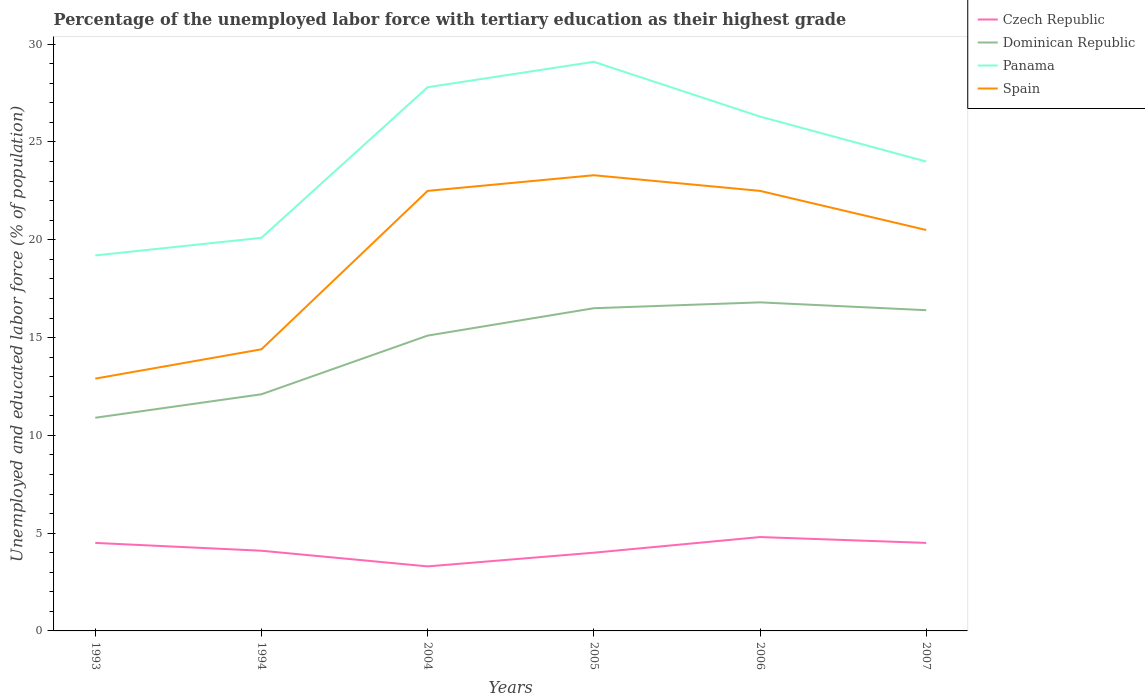How many different coloured lines are there?
Make the answer very short. 4. Is the number of lines equal to the number of legend labels?
Give a very brief answer. Yes. Across all years, what is the maximum percentage of the unemployed labor force with tertiary education in Czech Republic?
Keep it short and to the point. 3.3. What is the total percentage of the unemployed labor force with tertiary education in Spain in the graph?
Offer a very short reply. 2. What is the difference between the highest and the second highest percentage of the unemployed labor force with tertiary education in Panama?
Offer a terse response. 9.9. What is the difference between the highest and the lowest percentage of the unemployed labor force with tertiary education in Spain?
Offer a terse response. 4. Does the graph contain any zero values?
Provide a succinct answer. No. How many legend labels are there?
Offer a very short reply. 4. How are the legend labels stacked?
Your answer should be compact. Vertical. What is the title of the graph?
Provide a short and direct response. Percentage of the unemployed labor force with tertiary education as their highest grade. Does "World" appear as one of the legend labels in the graph?
Make the answer very short. No. What is the label or title of the Y-axis?
Offer a very short reply. Unemployed and educated labor force (% of population). What is the Unemployed and educated labor force (% of population) in Dominican Republic in 1993?
Provide a succinct answer. 10.9. What is the Unemployed and educated labor force (% of population) in Panama in 1993?
Offer a very short reply. 19.2. What is the Unemployed and educated labor force (% of population) of Spain in 1993?
Your answer should be compact. 12.9. What is the Unemployed and educated labor force (% of population) of Czech Republic in 1994?
Your answer should be very brief. 4.1. What is the Unemployed and educated labor force (% of population) in Dominican Republic in 1994?
Make the answer very short. 12.1. What is the Unemployed and educated labor force (% of population) of Panama in 1994?
Make the answer very short. 20.1. What is the Unemployed and educated labor force (% of population) of Spain in 1994?
Provide a succinct answer. 14.4. What is the Unemployed and educated labor force (% of population) of Czech Republic in 2004?
Ensure brevity in your answer.  3.3. What is the Unemployed and educated labor force (% of population) in Dominican Republic in 2004?
Your answer should be compact. 15.1. What is the Unemployed and educated labor force (% of population) of Panama in 2004?
Make the answer very short. 27.8. What is the Unemployed and educated labor force (% of population) of Panama in 2005?
Provide a short and direct response. 29.1. What is the Unemployed and educated labor force (% of population) of Spain in 2005?
Offer a terse response. 23.3. What is the Unemployed and educated labor force (% of population) of Czech Republic in 2006?
Your answer should be compact. 4.8. What is the Unemployed and educated labor force (% of population) of Dominican Republic in 2006?
Keep it short and to the point. 16.8. What is the Unemployed and educated labor force (% of population) of Panama in 2006?
Ensure brevity in your answer.  26.3. What is the Unemployed and educated labor force (% of population) in Czech Republic in 2007?
Keep it short and to the point. 4.5. What is the Unemployed and educated labor force (% of population) of Dominican Republic in 2007?
Give a very brief answer. 16.4. What is the Unemployed and educated labor force (% of population) of Spain in 2007?
Provide a succinct answer. 20.5. Across all years, what is the maximum Unemployed and educated labor force (% of population) in Czech Republic?
Keep it short and to the point. 4.8. Across all years, what is the maximum Unemployed and educated labor force (% of population) in Dominican Republic?
Ensure brevity in your answer.  16.8. Across all years, what is the maximum Unemployed and educated labor force (% of population) of Panama?
Give a very brief answer. 29.1. Across all years, what is the maximum Unemployed and educated labor force (% of population) of Spain?
Ensure brevity in your answer.  23.3. Across all years, what is the minimum Unemployed and educated labor force (% of population) of Czech Republic?
Your answer should be very brief. 3.3. Across all years, what is the minimum Unemployed and educated labor force (% of population) of Dominican Republic?
Offer a very short reply. 10.9. Across all years, what is the minimum Unemployed and educated labor force (% of population) of Panama?
Your response must be concise. 19.2. Across all years, what is the minimum Unemployed and educated labor force (% of population) of Spain?
Your response must be concise. 12.9. What is the total Unemployed and educated labor force (% of population) of Czech Republic in the graph?
Provide a short and direct response. 25.2. What is the total Unemployed and educated labor force (% of population) in Dominican Republic in the graph?
Keep it short and to the point. 87.8. What is the total Unemployed and educated labor force (% of population) in Panama in the graph?
Offer a very short reply. 146.5. What is the total Unemployed and educated labor force (% of population) in Spain in the graph?
Your answer should be compact. 116.1. What is the difference between the Unemployed and educated labor force (% of population) of Dominican Republic in 1993 and that in 1994?
Your answer should be compact. -1.2. What is the difference between the Unemployed and educated labor force (% of population) of Czech Republic in 1993 and that in 2004?
Keep it short and to the point. 1.2. What is the difference between the Unemployed and educated labor force (% of population) in Dominican Republic in 1993 and that in 2004?
Your response must be concise. -4.2. What is the difference between the Unemployed and educated labor force (% of population) of Dominican Republic in 1993 and that in 2005?
Keep it short and to the point. -5.6. What is the difference between the Unemployed and educated labor force (% of population) in Panama in 1993 and that in 2005?
Offer a very short reply. -9.9. What is the difference between the Unemployed and educated labor force (% of population) in Spain in 1993 and that in 2005?
Offer a terse response. -10.4. What is the difference between the Unemployed and educated labor force (% of population) of Czech Republic in 1993 and that in 2006?
Ensure brevity in your answer.  -0.3. What is the difference between the Unemployed and educated labor force (% of population) in Dominican Republic in 1993 and that in 2006?
Give a very brief answer. -5.9. What is the difference between the Unemployed and educated labor force (% of population) of Spain in 1993 and that in 2006?
Provide a succinct answer. -9.6. What is the difference between the Unemployed and educated labor force (% of population) of Dominican Republic in 1993 and that in 2007?
Make the answer very short. -5.5. What is the difference between the Unemployed and educated labor force (% of population) of Spain in 1993 and that in 2007?
Ensure brevity in your answer.  -7.6. What is the difference between the Unemployed and educated labor force (% of population) of Czech Republic in 1994 and that in 2004?
Your response must be concise. 0.8. What is the difference between the Unemployed and educated labor force (% of population) of Dominican Republic in 1994 and that in 2004?
Keep it short and to the point. -3. What is the difference between the Unemployed and educated labor force (% of population) in Spain in 1994 and that in 2004?
Give a very brief answer. -8.1. What is the difference between the Unemployed and educated labor force (% of population) in Czech Republic in 1994 and that in 2005?
Ensure brevity in your answer.  0.1. What is the difference between the Unemployed and educated labor force (% of population) of Spain in 1994 and that in 2005?
Offer a very short reply. -8.9. What is the difference between the Unemployed and educated labor force (% of population) in Dominican Republic in 1994 and that in 2006?
Give a very brief answer. -4.7. What is the difference between the Unemployed and educated labor force (% of population) in Panama in 1994 and that in 2006?
Your answer should be very brief. -6.2. What is the difference between the Unemployed and educated labor force (% of population) in Spain in 1994 and that in 2006?
Offer a very short reply. -8.1. What is the difference between the Unemployed and educated labor force (% of population) in Dominican Republic in 1994 and that in 2007?
Offer a terse response. -4.3. What is the difference between the Unemployed and educated labor force (% of population) of Spain in 2004 and that in 2005?
Provide a short and direct response. -0.8. What is the difference between the Unemployed and educated labor force (% of population) of Dominican Republic in 2004 and that in 2006?
Ensure brevity in your answer.  -1.7. What is the difference between the Unemployed and educated labor force (% of population) of Czech Republic in 2004 and that in 2007?
Give a very brief answer. -1.2. What is the difference between the Unemployed and educated labor force (% of population) in Spain in 2004 and that in 2007?
Offer a terse response. 2. What is the difference between the Unemployed and educated labor force (% of population) in Czech Republic in 2005 and that in 2006?
Make the answer very short. -0.8. What is the difference between the Unemployed and educated labor force (% of population) in Panama in 2005 and that in 2006?
Your response must be concise. 2.8. What is the difference between the Unemployed and educated labor force (% of population) in Spain in 2005 and that in 2006?
Keep it short and to the point. 0.8. What is the difference between the Unemployed and educated labor force (% of population) of Czech Republic in 2005 and that in 2007?
Give a very brief answer. -0.5. What is the difference between the Unemployed and educated labor force (% of population) of Dominican Republic in 2005 and that in 2007?
Ensure brevity in your answer.  0.1. What is the difference between the Unemployed and educated labor force (% of population) of Panama in 2005 and that in 2007?
Make the answer very short. 5.1. What is the difference between the Unemployed and educated labor force (% of population) in Dominican Republic in 2006 and that in 2007?
Your answer should be very brief. 0.4. What is the difference between the Unemployed and educated labor force (% of population) in Panama in 2006 and that in 2007?
Your answer should be very brief. 2.3. What is the difference between the Unemployed and educated labor force (% of population) in Spain in 2006 and that in 2007?
Give a very brief answer. 2. What is the difference between the Unemployed and educated labor force (% of population) of Czech Republic in 1993 and the Unemployed and educated labor force (% of population) of Dominican Republic in 1994?
Provide a succinct answer. -7.6. What is the difference between the Unemployed and educated labor force (% of population) in Czech Republic in 1993 and the Unemployed and educated labor force (% of population) in Panama in 1994?
Your answer should be very brief. -15.6. What is the difference between the Unemployed and educated labor force (% of population) of Czech Republic in 1993 and the Unemployed and educated labor force (% of population) of Spain in 1994?
Your answer should be compact. -9.9. What is the difference between the Unemployed and educated labor force (% of population) in Panama in 1993 and the Unemployed and educated labor force (% of population) in Spain in 1994?
Provide a succinct answer. 4.8. What is the difference between the Unemployed and educated labor force (% of population) of Czech Republic in 1993 and the Unemployed and educated labor force (% of population) of Dominican Republic in 2004?
Provide a succinct answer. -10.6. What is the difference between the Unemployed and educated labor force (% of population) of Czech Republic in 1993 and the Unemployed and educated labor force (% of population) of Panama in 2004?
Make the answer very short. -23.3. What is the difference between the Unemployed and educated labor force (% of population) in Czech Republic in 1993 and the Unemployed and educated labor force (% of population) in Spain in 2004?
Your answer should be very brief. -18. What is the difference between the Unemployed and educated labor force (% of population) in Dominican Republic in 1993 and the Unemployed and educated labor force (% of population) in Panama in 2004?
Your response must be concise. -16.9. What is the difference between the Unemployed and educated labor force (% of population) in Dominican Republic in 1993 and the Unemployed and educated labor force (% of population) in Spain in 2004?
Keep it short and to the point. -11.6. What is the difference between the Unemployed and educated labor force (% of population) in Czech Republic in 1993 and the Unemployed and educated labor force (% of population) in Dominican Republic in 2005?
Give a very brief answer. -12. What is the difference between the Unemployed and educated labor force (% of population) in Czech Republic in 1993 and the Unemployed and educated labor force (% of population) in Panama in 2005?
Give a very brief answer. -24.6. What is the difference between the Unemployed and educated labor force (% of population) in Czech Republic in 1993 and the Unemployed and educated labor force (% of population) in Spain in 2005?
Offer a very short reply. -18.8. What is the difference between the Unemployed and educated labor force (% of population) in Dominican Republic in 1993 and the Unemployed and educated labor force (% of population) in Panama in 2005?
Make the answer very short. -18.2. What is the difference between the Unemployed and educated labor force (% of population) in Czech Republic in 1993 and the Unemployed and educated labor force (% of population) in Panama in 2006?
Provide a succinct answer. -21.8. What is the difference between the Unemployed and educated labor force (% of population) of Czech Republic in 1993 and the Unemployed and educated labor force (% of population) of Spain in 2006?
Ensure brevity in your answer.  -18. What is the difference between the Unemployed and educated labor force (% of population) in Dominican Republic in 1993 and the Unemployed and educated labor force (% of population) in Panama in 2006?
Your response must be concise. -15.4. What is the difference between the Unemployed and educated labor force (% of population) of Dominican Republic in 1993 and the Unemployed and educated labor force (% of population) of Spain in 2006?
Keep it short and to the point. -11.6. What is the difference between the Unemployed and educated labor force (% of population) of Panama in 1993 and the Unemployed and educated labor force (% of population) of Spain in 2006?
Your answer should be compact. -3.3. What is the difference between the Unemployed and educated labor force (% of population) in Czech Republic in 1993 and the Unemployed and educated labor force (% of population) in Dominican Republic in 2007?
Your response must be concise. -11.9. What is the difference between the Unemployed and educated labor force (% of population) in Czech Republic in 1993 and the Unemployed and educated labor force (% of population) in Panama in 2007?
Give a very brief answer. -19.5. What is the difference between the Unemployed and educated labor force (% of population) of Panama in 1993 and the Unemployed and educated labor force (% of population) of Spain in 2007?
Give a very brief answer. -1.3. What is the difference between the Unemployed and educated labor force (% of population) in Czech Republic in 1994 and the Unemployed and educated labor force (% of population) in Dominican Republic in 2004?
Offer a terse response. -11. What is the difference between the Unemployed and educated labor force (% of population) in Czech Republic in 1994 and the Unemployed and educated labor force (% of population) in Panama in 2004?
Offer a terse response. -23.7. What is the difference between the Unemployed and educated labor force (% of population) of Czech Republic in 1994 and the Unemployed and educated labor force (% of population) of Spain in 2004?
Offer a very short reply. -18.4. What is the difference between the Unemployed and educated labor force (% of population) in Dominican Republic in 1994 and the Unemployed and educated labor force (% of population) in Panama in 2004?
Offer a terse response. -15.7. What is the difference between the Unemployed and educated labor force (% of population) in Dominican Republic in 1994 and the Unemployed and educated labor force (% of population) in Spain in 2004?
Your response must be concise. -10.4. What is the difference between the Unemployed and educated labor force (% of population) in Panama in 1994 and the Unemployed and educated labor force (% of population) in Spain in 2004?
Provide a succinct answer. -2.4. What is the difference between the Unemployed and educated labor force (% of population) in Czech Republic in 1994 and the Unemployed and educated labor force (% of population) in Spain in 2005?
Your answer should be compact. -19.2. What is the difference between the Unemployed and educated labor force (% of population) of Dominican Republic in 1994 and the Unemployed and educated labor force (% of population) of Panama in 2005?
Ensure brevity in your answer.  -17. What is the difference between the Unemployed and educated labor force (% of population) in Panama in 1994 and the Unemployed and educated labor force (% of population) in Spain in 2005?
Make the answer very short. -3.2. What is the difference between the Unemployed and educated labor force (% of population) of Czech Republic in 1994 and the Unemployed and educated labor force (% of population) of Dominican Republic in 2006?
Provide a succinct answer. -12.7. What is the difference between the Unemployed and educated labor force (% of population) of Czech Republic in 1994 and the Unemployed and educated labor force (% of population) of Panama in 2006?
Give a very brief answer. -22.2. What is the difference between the Unemployed and educated labor force (% of population) of Czech Republic in 1994 and the Unemployed and educated labor force (% of population) of Spain in 2006?
Your answer should be compact. -18.4. What is the difference between the Unemployed and educated labor force (% of population) in Dominican Republic in 1994 and the Unemployed and educated labor force (% of population) in Panama in 2006?
Offer a terse response. -14.2. What is the difference between the Unemployed and educated labor force (% of population) of Dominican Republic in 1994 and the Unemployed and educated labor force (% of population) of Spain in 2006?
Your answer should be compact. -10.4. What is the difference between the Unemployed and educated labor force (% of population) in Panama in 1994 and the Unemployed and educated labor force (% of population) in Spain in 2006?
Make the answer very short. -2.4. What is the difference between the Unemployed and educated labor force (% of population) in Czech Republic in 1994 and the Unemployed and educated labor force (% of population) in Dominican Republic in 2007?
Make the answer very short. -12.3. What is the difference between the Unemployed and educated labor force (% of population) in Czech Republic in 1994 and the Unemployed and educated labor force (% of population) in Panama in 2007?
Make the answer very short. -19.9. What is the difference between the Unemployed and educated labor force (% of population) of Czech Republic in 1994 and the Unemployed and educated labor force (% of population) of Spain in 2007?
Provide a short and direct response. -16.4. What is the difference between the Unemployed and educated labor force (% of population) in Dominican Republic in 1994 and the Unemployed and educated labor force (% of population) in Panama in 2007?
Offer a terse response. -11.9. What is the difference between the Unemployed and educated labor force (% of population) in Dominican Republic in 1994 and the Unemployed and educated labor force (% of population) in Spain in 2007?
Give a very brief answer. -8.4. What is the difference between the Unemployed and educated labor force (% of population) of Czech Republic in 2004 and the Unemployed and educated labor force (% of population) of Panama in 2005?
Your answer should be very brief. -25.8. What is the difference between the Unemployed and educated labor force (% of population) in Czech Republic in 2004 and the Unemployed and educated labor force (% of population) in Spain in 2005?
Keep it short and to the point. -20. What is the difference between the Unemployed and educated labor force (% of population) of Czech Republic in 2004 and the Unemployed and educated labor force (% of population) of Dominican Republic in 2006?
Make the answer very short. -13.5. What is the difference between the Unemployed and educated labor force (% of population) of Czech Republic in 2004 and the Unemployed and educated labor force (% of population) of Spain in 2006?
Your answer should be compact. -19.2. What is the difference between the Unemployed and educated labor force (% of population) of Dominican Republic in 2004 and the Unemployed and educated labor force (% of population) of Panama in 2006?
Give a very brief answer. -11.2. What is the difference between the Unemployed and educated labor force (% of population) of Dominican Republic in 2004 and the Unemployed and educated labor force (% of population) of Spain in 2006?
Your response must be concise. -7.4. What is the difference between the Unemployed and educated labor force (% of population) in Panama in 2004 and the Unemployed and educated labor force (% of population) in Spain in 2006?
Keep it short and to the point. 5.3. What is the difference between the Unemployed and educated labor force (% of population) in Czech Republic in 2004 and the Unemployed and educated labor force (% of population) in Dominican Republic in 2007?
Provide a succinct answer. -13.1. What is the difference between the Unemployed and educated labor force (% of population) in Czech Republic in 2004 and the Unemployed and educated labor force (% of population) in Panama in 2007?
Offer a very short reply. -20.7. What is the difference between the Unemployed and educated labor force (% of population) in Czech Republic in 2004 and the Unemployed and educated labor force (% of population) in Spain in 2007?
Your answer should be compact. -17.2. What is the difference between the Unemployed and educated labor force (% of population) of Dominican Republic in 2004 and the Unemployed and educated labor force (% of population) of Panama in 2007?
Make the answer very short. -8.9. What is the difference between the Unemployed and educated labor force (% of population) of Dominican Republic in 2004 and the Unemployed and educated labor force (% of population) of Spain in 2007?
Make the answer very short. -5.4. What is the difference between the Unemployed and educated labor force (% of population) of Panama in 2004 and the Unemployed and educated labor force (% of population) of Spain in 2007?
Give a very brief answer. 7.3. What is the difference between the Unemployed and educated labor force (% of population) of Czech Republic in 2005 and the Unemployed and educated labor force (% of population) of Dominican Republic in 2006?
Make the answer very short. -12.8. What is the difference between the Unemployed and educated labor force (% of population) in Czech Republic in 2005 and the Unemployed and educated labor force (% of population) in Panama in 2006?
Provide a short and direct response. -22.3. What is the difference between the Unemployed and educated labor force (% of population) in Czech Republic in 2005 and the Unemployed and educated labor force (% of population) in Spain in 2006?
Offer a terse response. -18.5. What is the difference between the Unemployed and educated labor force (% of population) of Czech Republic in 2005 and the Unemployed and educated labor force (% of population) of Panama in 2007?
Your answer should be very brief. -20. What is the difference between the Unemployed and educated labor force (% of population) of Czech Republic in 2005 and the Unemployed and educated labor force (% of population) of Spain in 2007?
Make the answer very short. -16.5. What is the difference between the Unemployed and educated labor force (% of population) of Dominican Republic in 2005 and the Unemployed and educated labor force (% of population) of Spain in 2007?
Provide a short and direct response. -4. What is the difference between the Unemployed and educated labor force (% of population) in Czech Republic in 2006 and the Unemployed and educated labor force (% of population) in Dominican Republic in 2007?
Provide a short and direct response. -11.6. What is the difference between the Unemployed and educated labor force (% of population) of Czech Republic in 2006 and the Unemployed and educated labor force (% of population) of Panama in 2007?
Offer a terse response. -19.2. What is the difference between the Unemployed and educated labor force (% of population) of Czech Republic in 2006 and the Unemployed and educated labor force (% of population) of Spain in 2007?
Offer a very short reply. -15.7. What is the difference between the Unemployed and educated labor force (% of population) of Dominican Republic in 2006 and the Unemployed and educated labor force (% of population) of Panama in 2007?
Provide a short and direct response. -7.2. What is the average Unemployed and educated labor force (% of population) of Dominican Republic per year?
Offer a terse response. 14.63. What is the average Unemployed and educated labor force (% of population) of Panama per year?
Offer a very short reply. 24.42. What is the average Unemployed and educated labor force (% of population) of Spain per year?
Your answer should be compact. 19.35. In the year 1993, what is the difference between the Unemployed and educated labor force (% of population) in Czech Republic and Unemployed and educated labor force (% of population) in Panama?
Offer a terse response. -14.7. In the year 1993, what is the difference between the Unemployed and educated labor force (% of population) of Dominican Republic and Unemployed and educated labor force (% of population) of Panama?
Ensure brevity in your answer.  -8.3. In the year 1993, what is the difference between the Unemployed and educated labor force (% of population) of Dominican Republic and Unemployed and educated labor force (% of population) of Spain?
Provide a succinct answer. -2. In the year 1994, what is the difference between the Unemployed and educated labor force (% of population) of Czech Republic and Unemployed and educated labor force (% of population) of Dominican Republic?
Provide a succinct answer. -8. In the year 1994, what is the difference between the Unemployed and educated labor force (% of population) in Czech Republic and Unemployed and educated labor force (% of population) in Spain?
Offer a very short reply. -10.3. In the year 1994, what is the difference between the Unemployed and educated labor force (% of population) of Dominican Republic and Unemployed and educated labor force (% of population) of Panama?
Provide a short and direct response. -8. In the year 2004, what is the difference between the Unemployed and educated labor force (% of population) of Czech Republic and Unemployed and educated labor force (% of population) of Panama?
Offer a very short reply. -24.5. In the year 2004, what is the difference between the Unemployed and educated labor force (% of population) of Czech Republic and Unemployed and educated labor force (% of population) of Spain?
Offer a terse response. -19.2. In the year 2004, what is the difference between the Unemployed and educated labor force (% of population) in Dominican Republic and Unemployed and educated labor force (% of population) in Panama?
Your answer should be very brief. -12.7. In the year 2004, what is the difference between the Unemployed and educated labor force (% of population) of Dominican Republic and Unemployed and educated labor force (% of population) of Spain?
Make the answer very short. -7.4. In the year 2005, what is the difference between the Unemployed and educated labor force (% of population) in Czech Republic and Unemployed and educated labor force (% of population) in Panama?
Provide a short and direct response. -25.1. In the year 2005, what is the difference between the Unemployed and educated labor force (% of population) in Czech Republic and Unemployed and educated labor force (% of population) in Spain?
Provide a short and direct response. -19.3. In the year 2005, what is the difference between the Unemployed and educated labor force (% of population) in Dominican Republic and Unemployed and educated labor force (% of population) in Panama?
Ensure brevity in your answer.  -12.6. In the year 2006, what is the difference between the Unemployed and educated labor force (% of population) of Czech Republic and Unemployed and educated labor force (% of population) of Dominican Republic?
Your answer should be very brief. -12. In the year 2006, what is the difference between the Unemployed and educated labor force (% of population) in Czech Republic and Unemployed and educated labor force (% of population) in Panama?
Make the answer very short. -21.5. In the year 2006, what is the difference between the Unemployed and educated labor force (% of population) of Czech Republic and Unemployed and educated labor force (% of population) of Spain?
Provide a succinct answer. -17.7. In the year 2006, what is the difference between the Unemployed and educated labor force (% of population) of Dominican Republic and Unemployed and educated labor force (% of population) of Panama?
Keep it short and to the point. -9.5. In the year 2006, what is the difference between the Unemployed and educated labor force (% of population) in Dominican Republic and Unemployed and educated labor force (% of population) in Spain?
Provide a succinct answer. -5.7. In the year 2007, what is the difference between the Unemployed and educated labor force (% of population) in Czech Republic and Unemployed and educated labor force (% of population) in Dominican Republic?
Make the answer very short. -11.9. In the year 2007, what is the difference between the Unemployed and educated labor force (% of population) in Czech Republic and Unemployed and educated labor force (% of population) in Panama?
Make the answer very short. -19.5. In the year 2007, what is the difference between the Unemployed and educated labor force (% of population) in Dominican Republic and Unemployed and educated labor force (% of population) in Panama?
Provide a succinct answer. -7.6. In the year 2007, what is the difference between the Unemployed and educated labor force (% of population) in Dominican Republic and Unemployed and educated labor force (% of population) in Spain?
Your response must be concise. -4.1. In the year 2007, what is the difference between the Unemployed and educated labor force (% of population) in Panama and Unemployed and educated labor force (% of population) in Spain?
Ensure brevity in your answer.  3.5. What is the ratio of the Unemployed and educated labor force (% of population) in Czech Republic in 1993 to that in 1994?
Give a very brief answer. 1.1. What is the ratio of the Unemployed and educated labor force (% of population) in Dominican Republic in 1993 to that in 1994?
Your answer should be very brief. 0.9. What is the ratio of the Unemployed and educated labor force (% of population) in Panama in 1993 to that in 1994?
Make the answer very short. 0.96. What is the ratio of the Unemployed and educated labor force (% of population) in Spain in 1993 to that in 1994?
Offer a terse response. 0.9. What is the ratio of the Unemployed and educated labor force (% of population) in Czech Republic in 1993 to that in 2004?
Your answer should be very brief. 1.36. What is the ratio of the Unemployed and educated labor force (% of population) of Dominican Republic in 1993 to that in 2004?
Keep it short and to the point. 0.72. What is the ratio of the Unemployed and educated labor force (% of population) in Panama in 1993 to that in 2004?
Ensure brevity in your answer.  0.69. What is the ratio of the Unemployed and educated labor force (% of population) of Spain in 1993 to that in 2004?
Provide a short and direct response. 0.57. What is the ratio of the Unemployed and educated labor force (% of population) in Czech Republic in 1993 to that in 2005?
Offer a terse response. 1.12. What is the ratio of the Unemployed and educated labor force (% of population) of Dominican Republic in 1993 to that in 2005?
Provide a succinct answer. 0.66. What is the ratio of the Unemployed and educated labor force (% of population) in Panama in 1993 to that in 2005?
Keep it short and to the point. 0.66. What is the ratio of the Unemployed and educated labor force (% of population) of Spain in 1993 to that in 2005?
Offer a terse response. 0.55. What is the ratio of the Unemployed and educated labor force (% of population) in Dominican Republic in 1993 to that in 2006?
Make the answer very short. 0.65. What is the ratio of the Unemployed and educated labor force (% of population) of Panama in 1993 to that in 2006?
Provide a short and direct response. 0.73. What is the ratio of the Unemployed and educated labor force (% of population) of Spain in 1993 to that in 2006?
Your answer should be compact. 0.57. What is the ratio of the Unemployed and educated labor force (% of population) in Dominican Republic in 1993 to that in 2007?
Keep it short and to the point. 0.66. What is the ratio of the Unemployed and educated labor force (% of population) of Spain in 1993 to that in 2007?
Provide a succinct answer. 0.63. What is the ratio of the Unemployed and educated labor force (% of population) in Czech Republic in 1994 to that in 2004?
Your answer should be very brief. 1.24. What is the ratio of the Unemployed and educated labor force (% of population) of Dominican Republic in 1994 to that in 2004?
Provide a short and direct response. 0.8. What is the ratio of the Unemployed and educated labor force (% of population) of Panama in 1994 to that in 2004?
Your response must be concise. 0.72. What is the ratio of the Unemployed and educated labor force (% of population) in Spain in 1994 to that in 2004?
Give a very brief answer. 0.64. What is the ratio of the Unemployed and educated labor force (% of population) of Dominican Republic in 1994 to that in 2005?
Give a very brief answer. 0.73. What is the ratio of the Unemployed and educated labor force (% of population) in Panama in 1994 to that in 2005?
Give a very brief answer. 0.69. What is the ratio of the Unemployed and educated labor force (% of population) in Spain in 1994 to that in 2005?
Make the answer very short. 0.62. What is the ratio of the Unemployed and educated labor force (% of population) in Czech Republic in 1994 to that in 2006?
Provide a succinct answer. 0.85. What is the ratio of the Unemployed and educated labor force (% of population) of Dominican Republic in 1994 to that in 2006?
Your response must be concise. 0.72. What is the ratio of the Unemployed and educated labor force (% of population) of Panama in 1994 to that in 2006?
Your answer should be very brief. 0.76. What is the ratio of the Unemployed and educated labor force (% of population) of Spain in 1994 to that in 2006?
Offer a terse response. 0.64. What is the ratio of the Unemployed and educated labor force (% of population) in Czech Republic in 1994 to that in 2007?
Provide a succinct answer. 0.91. What is the ratio of the Unemployed and educated labor force (% of population) in Dominican Republic in 1994 to that in 2007?
Provide a short and direct response. 0.74. What is the ratio of the Unemployed and educated labor force (% of population) in Panama in 1994 to that in 2007?
Offer a terse response. 0.84. What is the ratio of the Unemployed and educated labor force (% of population) of Spain in 1994 to that in 2007?
Give a very brief answer. 0.7. What is the ratio of the Unemployed and educated labor force (% of population) of Czech Republic in 2004 to that in 2005?
Give a very brief answer. 0.82. What is the ratio of the Unemployed and educated labor force (% of population) of Dominican Republic in 2004 to that in 2005?
Your response must be concise. 0.92. What is the ratio of the Unemployed and educated labor force (% of population) in Panama in 2004 to that in 2005?
Offer a terse response. 0.96. What is the ratio of the Unemployed and educated labor force (% of population) in Spain in 2004 to that in 2005?
Offer a terse response. 0.97. What is the ratio of the Unemployed and educated labor force (% of population) of Czech Republic in 2004 to that in 2006?
Your response must be concise. 0.69. What is the ratio of the Unemployed and educated labor force (% of population) of Dominican Republic in 2004 to that in 2006?
Your answer should be very brief. 0.9. What is the ratio of the Unemployed and educated labor force (% of population) in Panama in 2004 to that in 2006?
Your response must be concise. 1.06. What is the ratio of the Unemployed and educated labor force (% of population) in Czech Republic in 2004 to that in 2007?
Your answer should be very brief. 0.73. What is the ratio of the Unemployed and educated labor force (% of population) in Dominican Republic in 2004 to that in 2007?
Provide a short and direct response. 0.92. What is the ratio of the Unemployed and educated labor force (% of population) in Panama in 2004 to that in 2007?
Offer a terse response. 1.16. What is the ratio of the Unemployed and educated labor force (% of population) in Spain in 2004 to that in 2007?
Make the answer very short. 1.1. What is the ratio of the Unemployed and educated labor force (% of population) of Czech Republic in 2005 to that in 2006?
Offer a very short reply. 0.83. What is the ratio of the Unemployed and educated labor force (% of population) in Dominican Republic in 2005 to that in 2006?
Your response must be concise. 0.98. What is the ratio of the Unemployed and educated labor force (% of population) of Panama in 2005 to that in 2006?
Give a very brief answer. 1.11. What is the ratio of the Unemployed and educated labor force (% of population) of Spain in 2005 to that in 2006?
Offer a terse response. 1.04. What is the ratio of the Unemployed and educated labor force (% of population) of Czech Republic in 2005 to that in 2007?
Ensure brevity in your answer.  0.89. What is the ratio of the Unemployed and educated labor force (% of population) of Panama in 2005 to that in 2007?
Give a very brief answer. 1.21. What is the ratio of the Unemployed and educated labor force (% of population) of Spain in 2005 to that in 2007?
Ensure brevity in your answer.  1.14. What is the ratio of the Unemployed and educated labor force (% of population) of Czech Republic in 2006 to that in 2007?
Ensure brevity in your answer.  1.07. What is the ratio of the Unemployed and educated labor force (% of population) in Dominican Republic in 2006 to that in 2007?
Your answer should be compact. 1.02. What is the ratio of the Unemployed and educated labor force (% of population) in Panama in 2006 to that in 2007?
Provide a short and direct response. 1.1. What is the ratio of the Unemployed and educated labor force (% of population) of Spain in 2006 to that in 2007?
Provide a succinct answer. 1.1. What is the difference between the highest and the second highest Unemployed and educated labor force (% of population) of Czech Republic?
Your answer should be compact. 0.3. What is the difference between the highest and the second highest Unemployed and educated labor force (% of population) in Panama?
Ensure brevity in your answer.  1.3. 